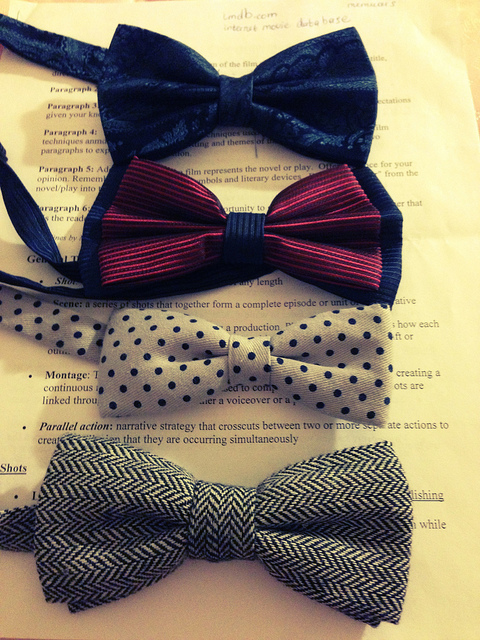Read all the text in this image. Paragraph and represents Shots action: Parallel Montage Paragraph 5 Paragraph 